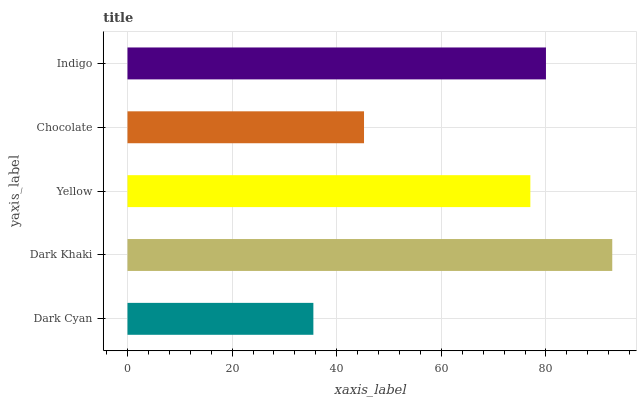Is Dark Cyan the minimum?
Answer yes or no. Yes. Is Dark Khaki the maximum?
Answer yes or no. Yes. Is Yellow the minimum?
Answer yes or no. No. Is Yellow the maximum?
Answer yes or no. No. Is Dark Khaki greater than Yellow?
Answer yes or no. Yes. Is Yellow less than Dark Khaki?
Answer yes or no. Yes. Is Yellow greater than Dark Khaki?
Answer yes or no. No. Is Dark Khaki less than Yellow?
Answer yes or no. No. Is Yellow the high median?
Answer yes or no. Yes. Is Yellow the low median?
Answer yes or no. Yes. Is Chocolate the high median?
Answer yes or no. No. Is Indigo the low median?
Answer yes or no. No. 